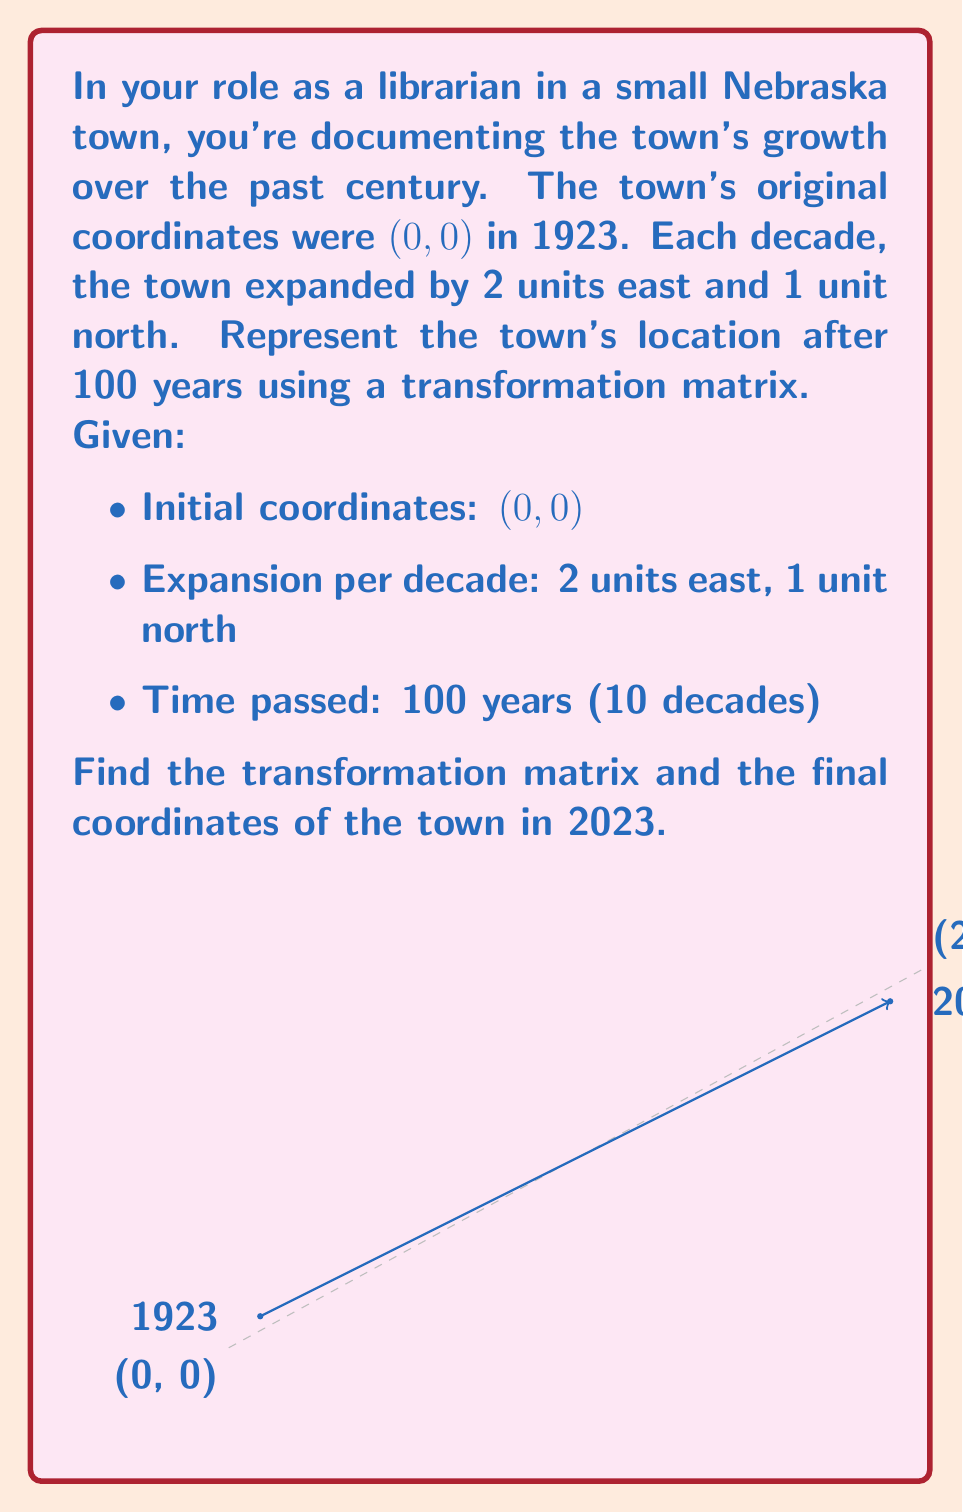Could you help me with this problem? Let's approach this step-by-step:

1) First, we need to determine the total movement in 100 years:
   - East movement: 2 units/decade × 10 decades = 20 units
   - North movement: 1 unit/decade × 10 decades = 10 units

2) We can represent this transformation as a matrix addition:

   $$ \begin{pmatrix} x' \\ y' \end{pmatrix} = \begin{pmatrix} x \\ y \end{pmatrix} + \begin{pmatrix} 20 \\ 10 \end{pmatrix} $$

3) To convert this into a single transformation matrix, we need to use homogeneous coordinates. We'll add a third coordinate (1) to our initial point:

   $$ \begin{pmatrix} x' \\ y' \\ 1 \end{pmatrix} = \begin{pmatrix} 1 & 0 & 20 \\ 0 & 1 & 10 \\ 0 & 0 & 1 \end{pmatrix} \begin{pmatrix} x \\ y \\ 1 \end{pmatrix} $$

4) This 3x3 matrix is our transformation matrix:

   $$ T = \begin{pmatrix} 1 & 0 & 20 \\ 0 & 1 & 10 \\ 0 & 0 & 1 \end{pmatrix} $$

5) To find the final coordinates, we apply this transformation to the initial point (0, 0):

   $$ \begin{pmatrix} x' \\ y' \\ 1 \end{pmatrix} = \begin{pmatrix} 1 & 0 & 20 \\ 0 & 1 & 10 \\ 0 & 0 & 1 \end{pmatrix} \begin{pmatrix} 0 \\ 0 \\ 1 \end{pmatrix} = \begin{pmatrix} 20 \\ 10 \\ 1 \end{pmatrix} $$

Therefore, the final coordinates of the town in 2023 are (20, 10).
Answer: $T = \begin{pmatrix} 1 & 0 & 20 \\ 0 & 1 & 10 \\ 0 & 0 & 1 \end{pmatrix}$, Final coordinates: (20, 10) 